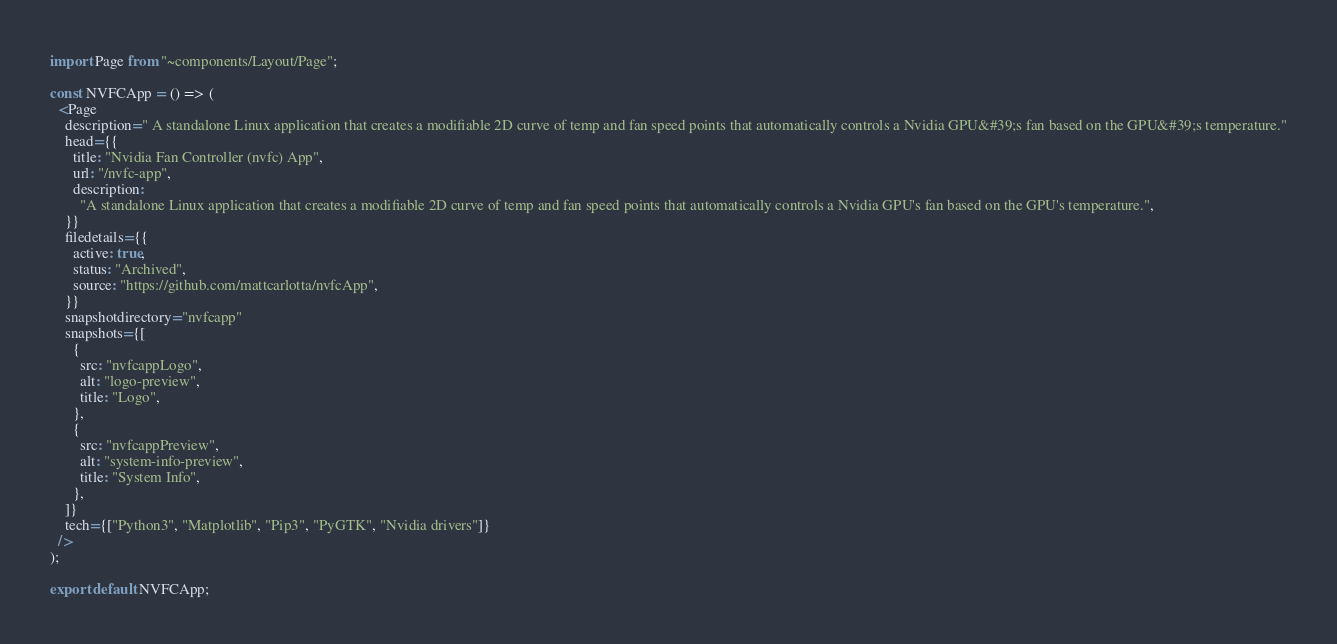<code> <loc_0><loc_0><loc_500><loc_500><_JavaScript_>import Page from "~components/Layout/Page";

const NVFCApp = () => (
  <Page
    description=" A standalone Linux application that creates a modifiable 2D curve of temp and fan speed points that automatically controls a Nvidia GPU&#39;s fan based on the GPU&#39;s temperature."
    head={{
      title: "Nvidia Fan Controller (nvfc) App",
      url: "/nvfc-app",
      description:
        "A standalone Linux application that creates a modifiable 2D curve of temp and fan speed points that automatically controls a Nvidia GPU's fan based on the GPU's temperature.",
    }}
    filedetails={{
      active: true,
      status: "Archived",
      source: "https://github.com/mattcarlotta/nvfcApp",
    }}
    snapshotdirectory="nvfcapp"
    snapshots={[
      {
        src: "nvfcappLogo",
        alt: "logo-preview",
        title: "Logo",
      },
      {
        src: "nvfcappPreview",
        alt: "system-info-preview",
        title: "System Info",
      },
    ]}
    tech={["Python3", "Matplotlib", "Pip3", "PyGTK", "Nvidia drivers"]}
  />
);

export default NVFCApp;
</code> 